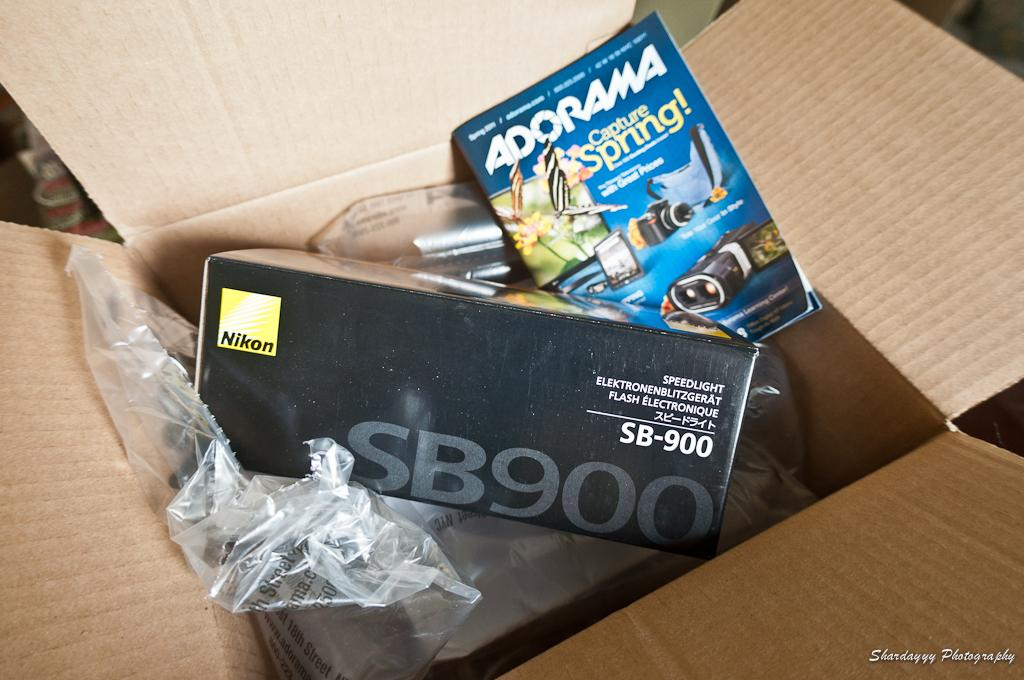<image>
Render a clear and concise summary of the photo. The books tells the reader how to capture spring. 